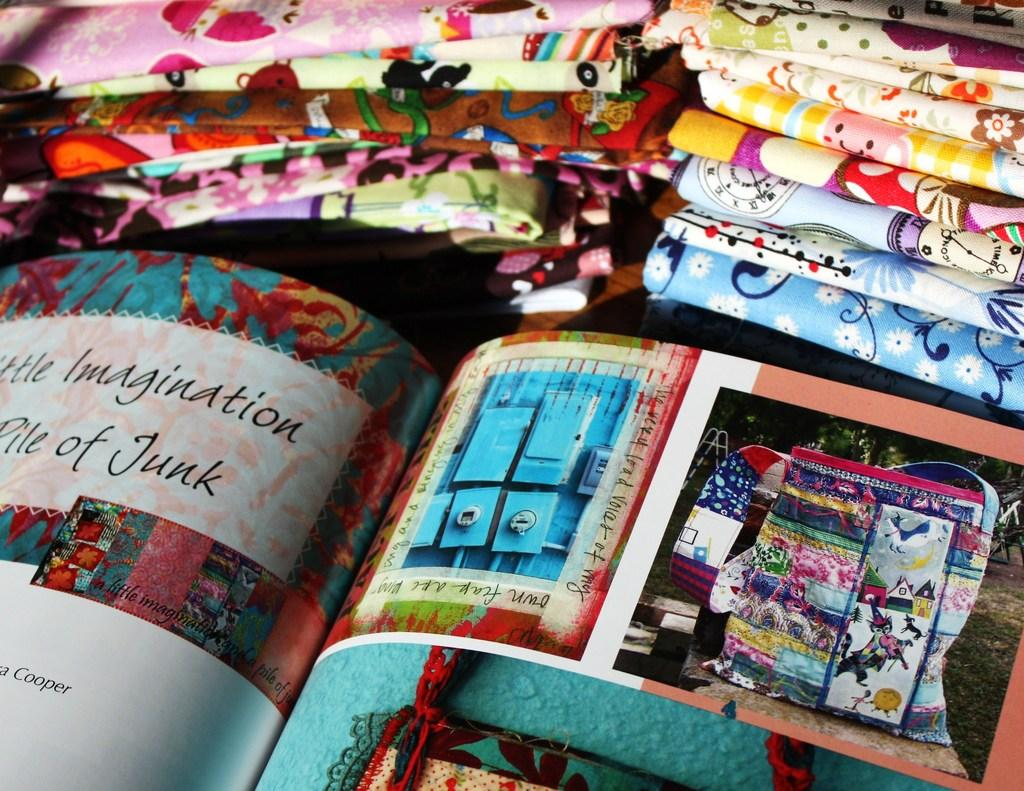<image>
Share a concise interpretation of the image provided. A book opened to the page to help spark your imagination from a pile of junk. 